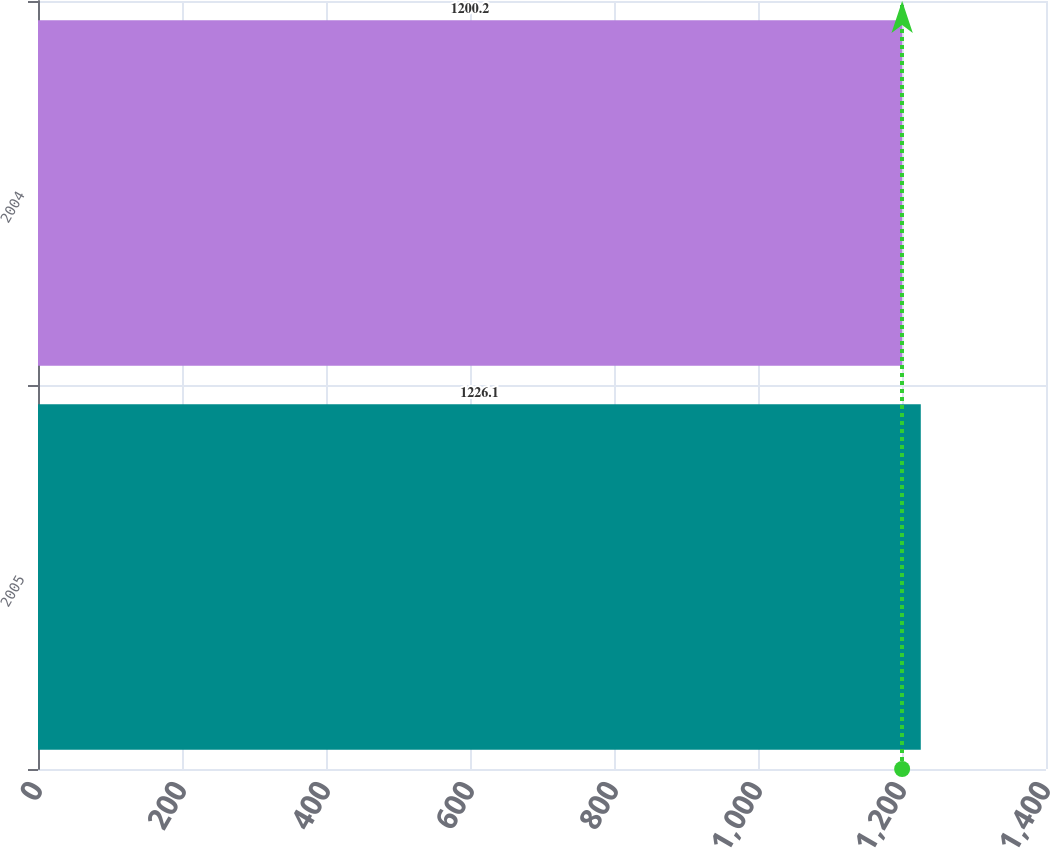<chart> <loc_0><loc_0><loc_500><loc_500><bar_chart><fcel>2005<fcel>2004<nl><fcel>1226.1<fcel>1200.2<nl></chart> 